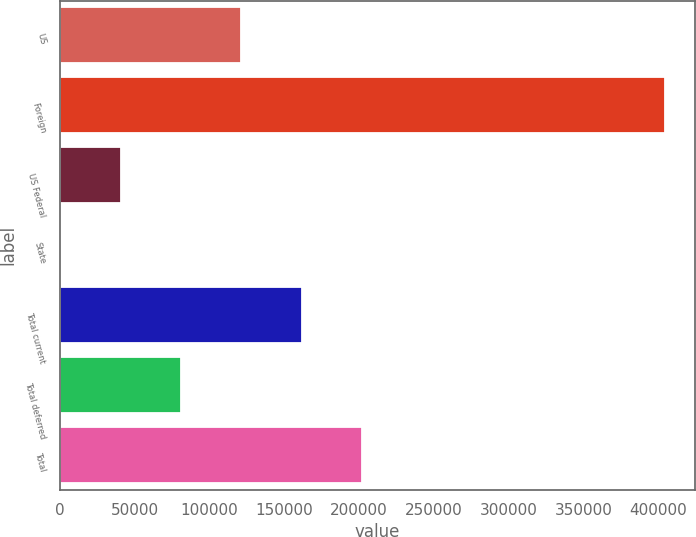Convert chart to OTSL. <chart><loc_0><loc_0><loc_500><loc_500><bar_chart><fcel>US<fcel>Foreign<fcel>US Federal<fcel>State<fcel>Total current<fcel>Total deferred<fcel>Total<nl><fcel>121278<fcel>404109<fcel>40468.5<fcel>64<fcel>161682<fcel>80873<fcel>202086<nl></chart> 